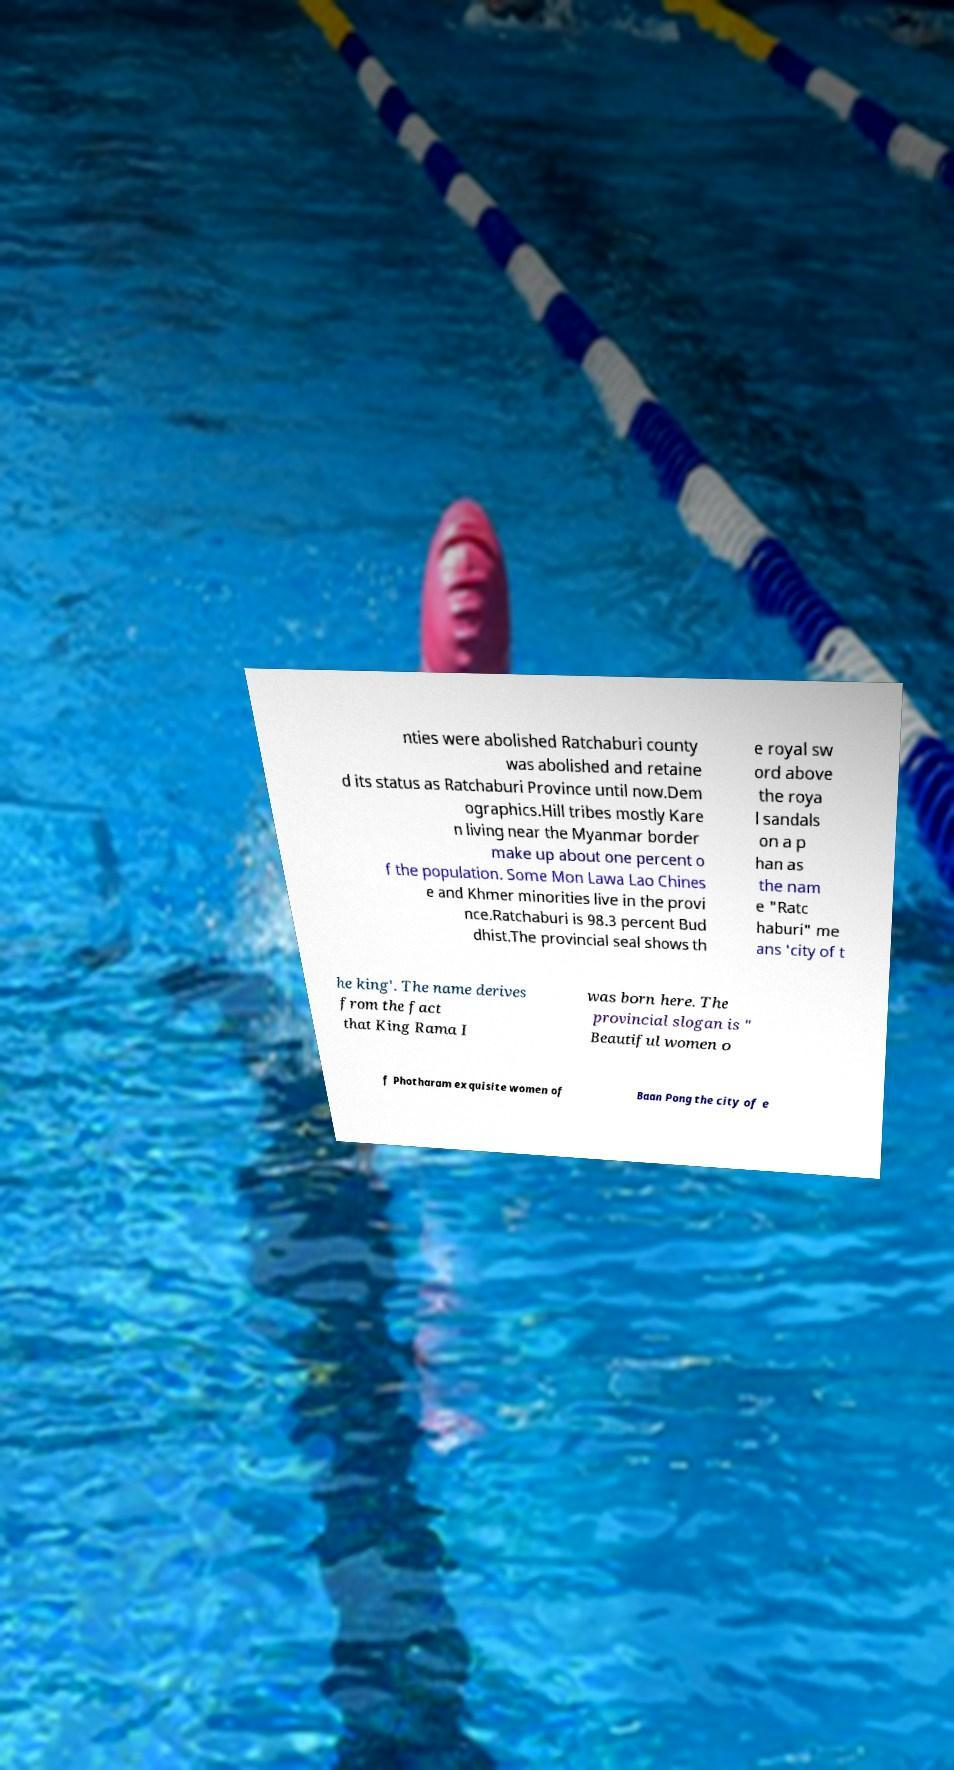Can you accurately transcribe the text from the provided image for me? nties were abolished Ratchaburi county was abolished and retaine d its status as Ratchaburi Province until now.Dem ographics.Hill tribes mostly Kare n living near the Myanmar border make up about one percent o f the population. Some Mon Lawa Lao Chines e and Khmer minorities live in the provi nce.Ratchaburi is 98.3 percent Bud dhist.The provincial seal shows th e royal sw ord above the roya l sandals on a p han as the nam e "Ratc haburi" me ans 'city of t he king'. The name derives from the fact that King Rama I was born here. The provincial slogan is " Beautiful women o f Photharam exquisite women of Baan Pong the city of e 